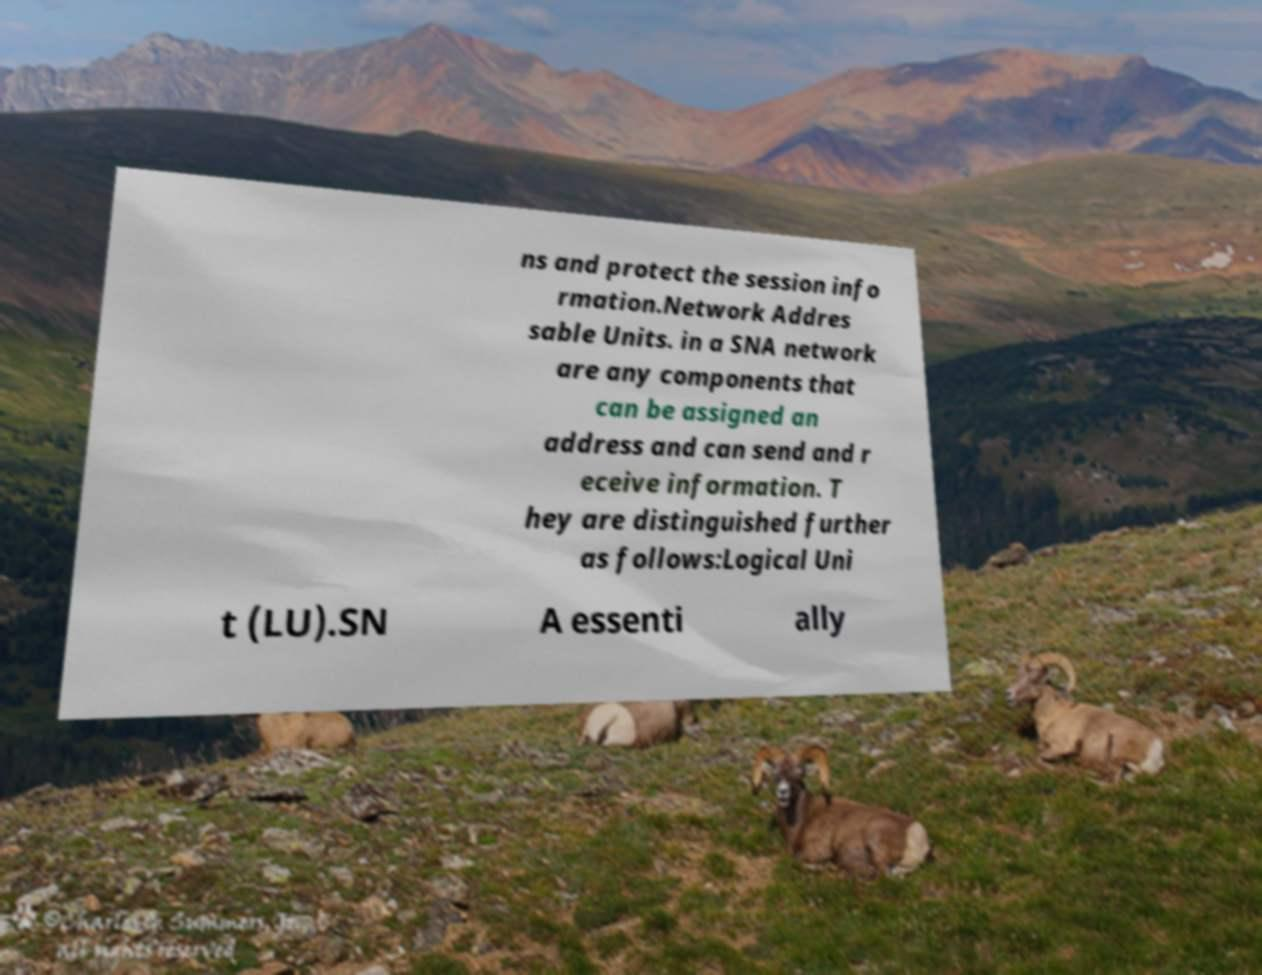Please read and relay the text visible in this image. What does it say? ns and protect the session info rmation.Network Addres sable Units. in a SNA network are any components that can be assigned an address and can send and r eceive information. T hey are distinguished further as follows:Logical Uni t (LU).SN A essenti ally 